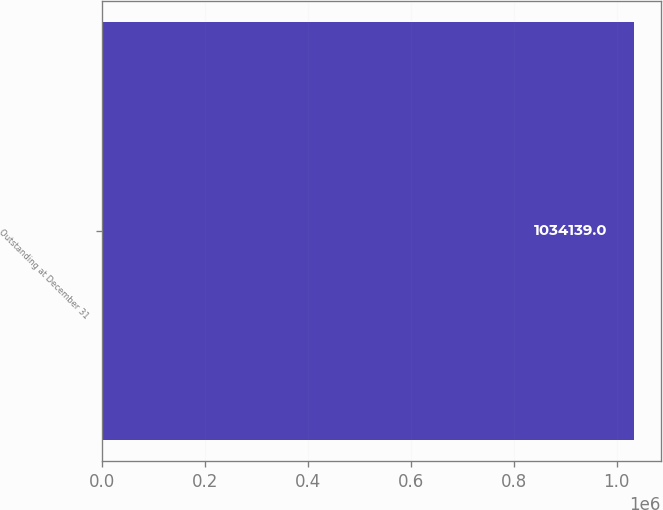Convert chart to OTSL. <chart><loc_0><loc_0><loc_500><loc_500><bar_chart><fcel>Outstanding at December 31<nl><fcel>1.03414e+06<nl></chart> 